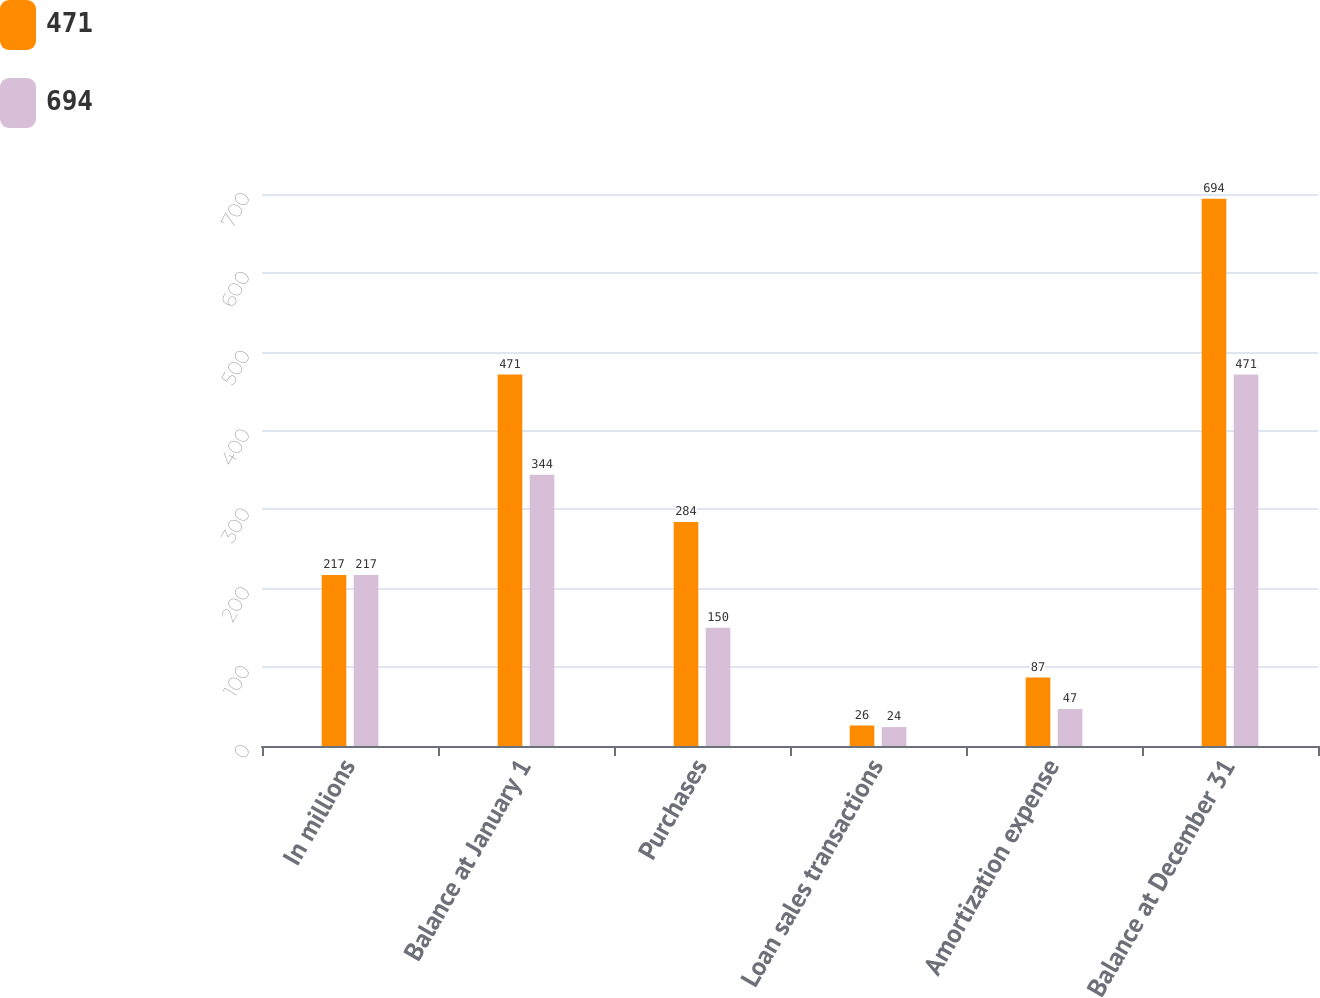Convert chart to OTSL. <chart><loc_0><loc_0><loc_500><loc_500><stacked_bar_chart><ecel><fcel>In millions<fcel>Balance at January 1<fcel>Purchases<fcel>Loan sales transactions<fcel>Amortization expense<fcel>Balance at December 31<nl><fcel>471<fcel>217<fcel>471<fcel>284<fcel>26<fcel>87<fcel>694<nl><fcel>694<fcel>217<fcel>344<fcel>150<fcel>24<fcel>47<fcel>471<nl></chart> 